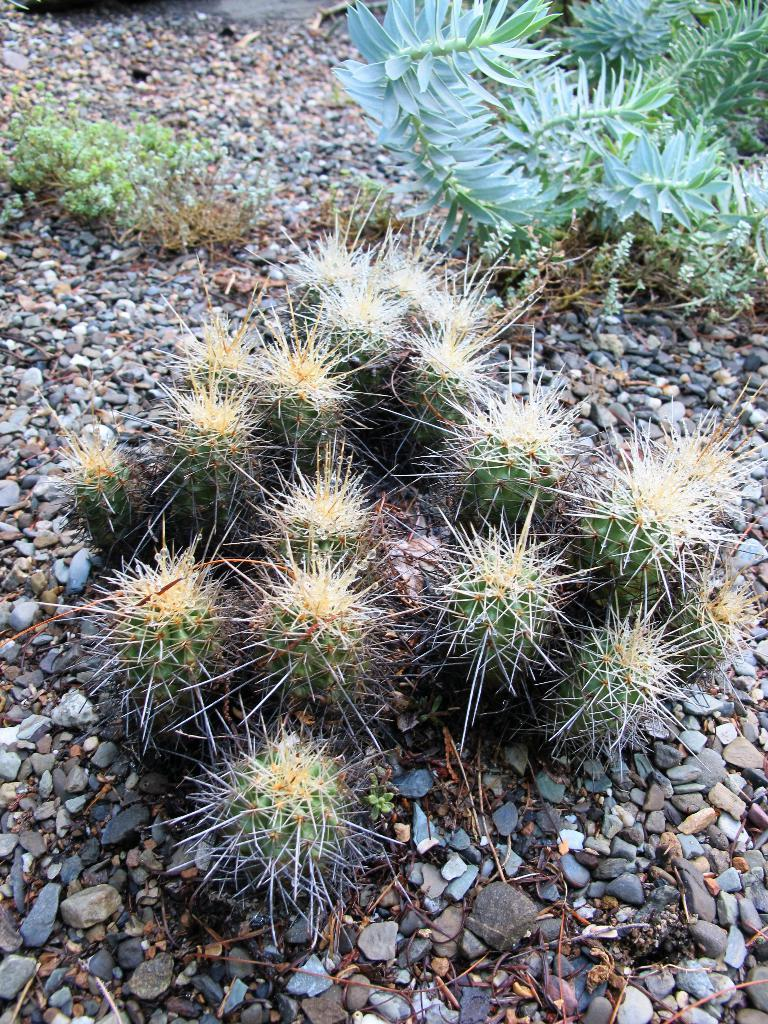Where was the image taken? The image was clicked outside. What type of plants can be seen in the foreground of the image? There are plants with prickles in the foreground. What type of ground surface is visible in the image? There is gravel visible in the image. What else can be seen in the image besides the plants with prickles? There are other plants visible in the image. Where is the shelf located in the image? There is no shelf present in the image. What type of stew is being prepared in the image? There is no stew being prepared in the image; it features plants and gravel. 